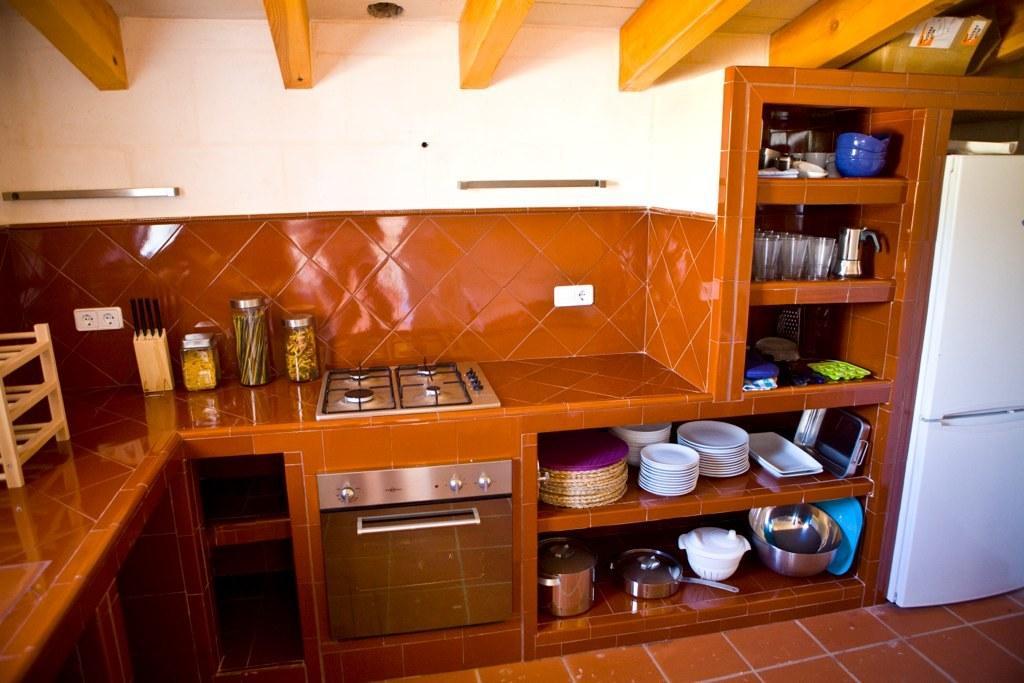In one or two sentences, can you explain what this image depicts? In the picture we can see stove besides microwave oven, there are some bottles which are on the surface, we can see some plates, bowls, glasses, jars and some other objects are arranged in the shelves and in the background of the picture there is a wall and there are switch sockets. 